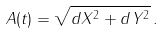<formula> <loc_0><loc_0><loc_500><loc_500>A ( t ) = \sqrt { d X ^ { 2 } + d Y ^ { 2 } } \, .</formula> 